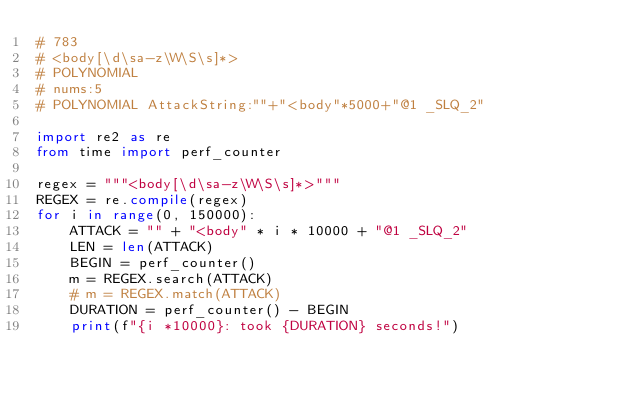Convert code to text. <code><loc_0><loc_0><loc_500><loc_500><_Python_># 783
# <body[\d\sa-z\W\S\s]*>
# POLYNOMIAL
# nums:5
# POLYNOMIAL AttackString:""+"<body"*5000+"@1 _SLQ_2"

import re2 as re
from time import perf_counter

regex = """<body[\d\sa-z\W\S\s]*>"""
REGEX = re.compile(regex)
for i in range(0, 150000):
    ATTACK = "" + "<body" * i * 10000 + "@1 _SLQ_2"
    LEN = len(ATTACK)
    BEGIN = perf_counter()
    m = REGEX.search(ATTACK)
    # m = REGEX.match(ATTACK)
    DURATION = perf_counter() - BEGIN
    print(f"{i *10000}: took {DURATION} seconds!")</code> 